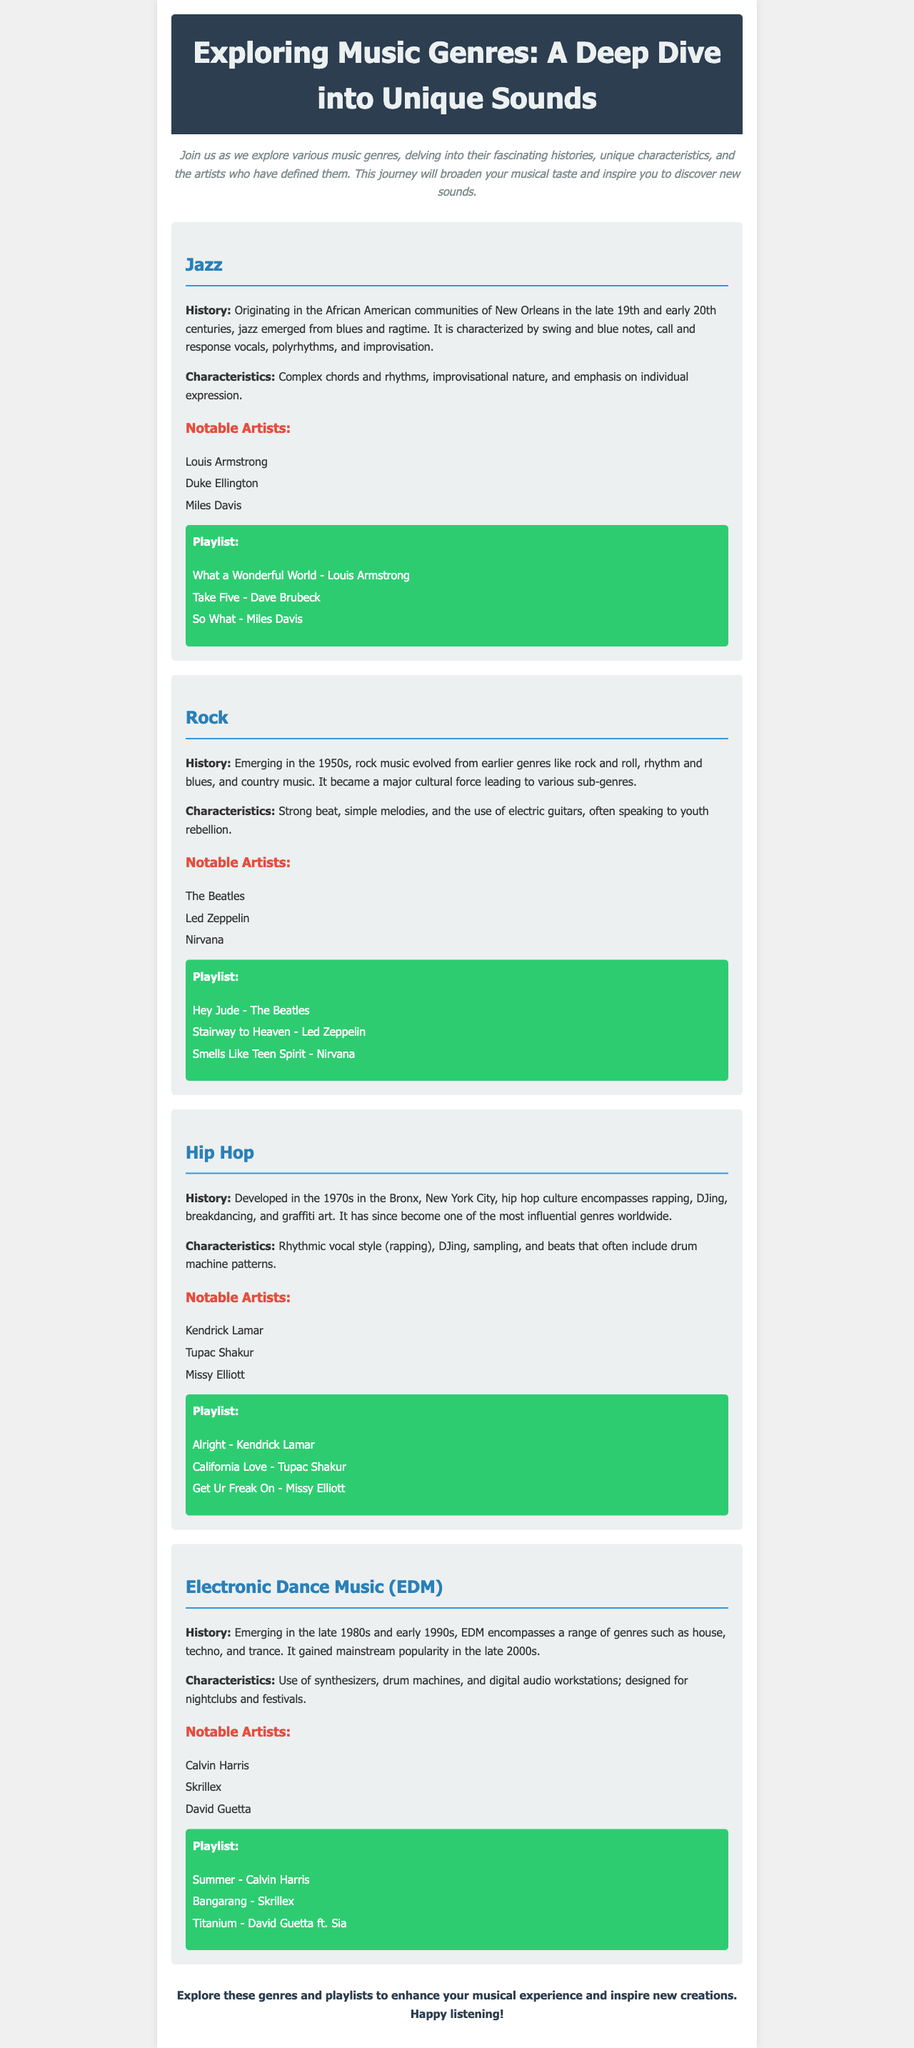What is the first genre discussed? The first genre discussed in the document is Jazz.
Answer: Jazz Who is a notable artist of Rock? A notable artist of Rock mentioned in the document is The Beatles.
Answer: The Beatles In which decade did Hip Hop develop? Hip Hop developed in the 1970s as indicated in the document.
Answer: 1970s What is one characteristic of Electronic Dance Music? One characteristic of Electronic Dance Music mentioned is the use of synthesizers.
Answer: Use of synthesizers Which genre emerged from the African American communities of New Orleans? The genre that emerged from the African American communities of New Orleans is Jazz.
Answer: Jazz How many artists are listed under the Hip Hop genre? The document lists three notable artists under the Hip Hop genre.
Answer: Three What color is the background of the playlist section? The background color of the playlist section is green.
Answer: Green Name one song from the Jazz playlist. One song from the Jazz playlist is "What a Wonderful World."
Answer: What a Wonderful World 